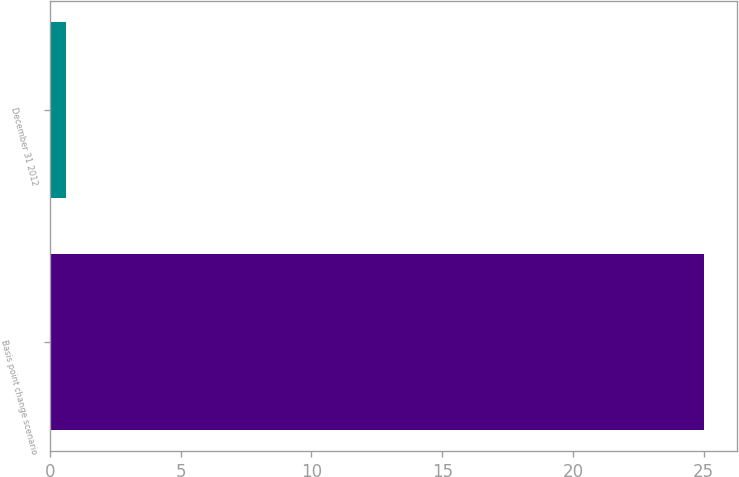<chart> <loc_0><loc_0><loc_500><loc_500><bar_chart><fcel>Basis point change scenario<fcel>December 31 2012<nl><fcel>25<fcel>0.6<nl></chart> 